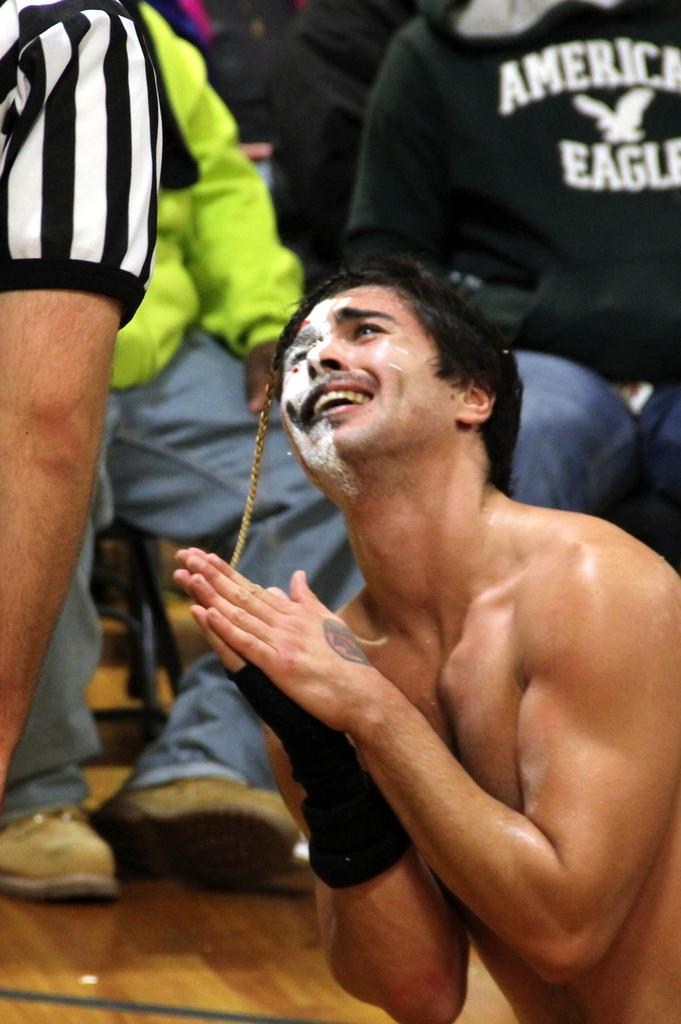Provide a one-sentence caption for the provided image. A shirtless man is posing with his palms pressed in front of a person wearing American eagle sweatshirt. 